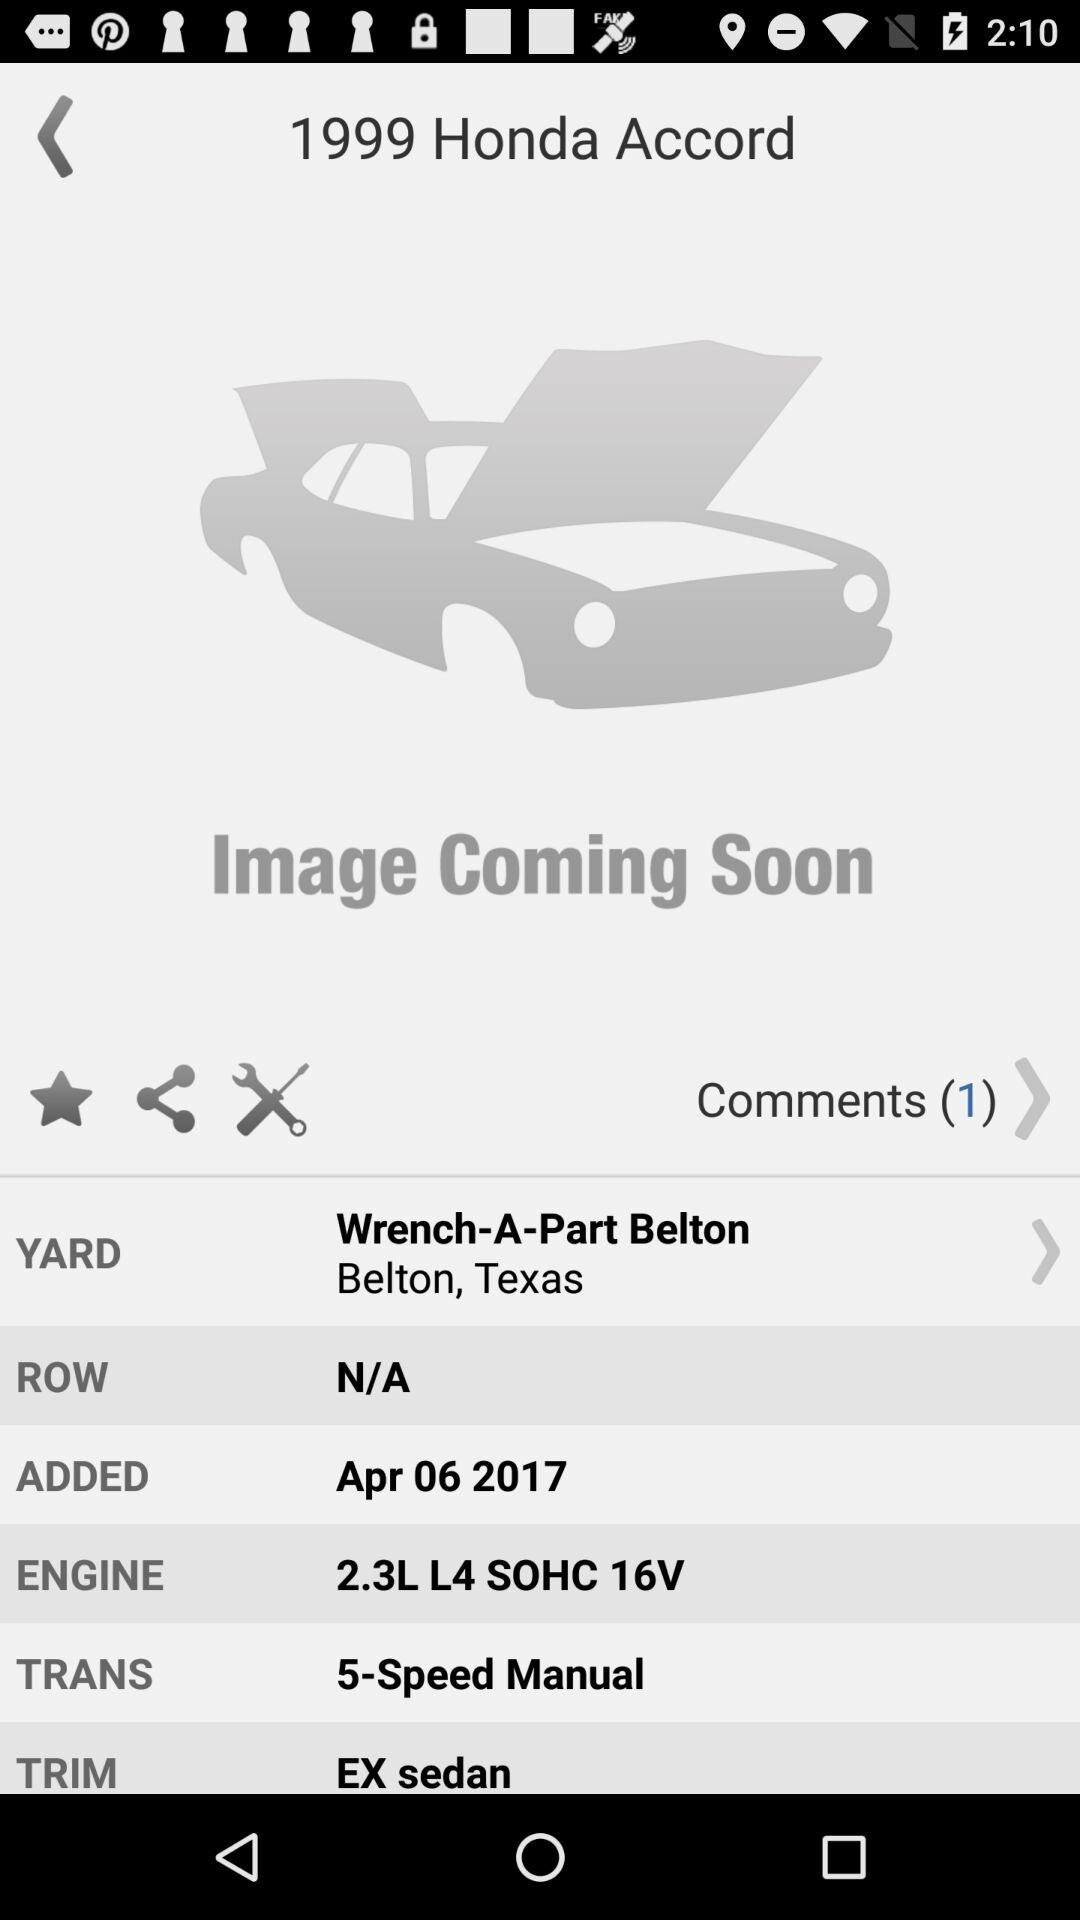What is the name of the engine? The engine name is "2.3L L4 SOHC 16V". 